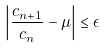<formula> <loc_0><loc_0><loc_500><loc_500>\left | \frac { c _ { n + 1 } } { c _ { n } } - \mu \right | \leq \epsilon</formula> 